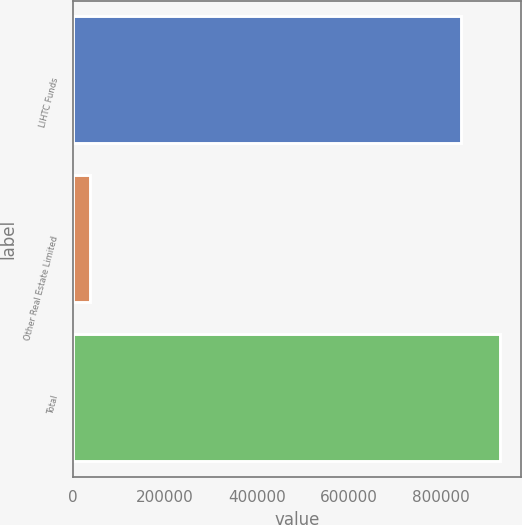Convert chart to OTSL. <chart><loc_0><loc_0><loc_500><loc_500><bar_chart><fcel>LIHTC Funds<fcel>Other Real Estate Limited<fcel>Total<nl><fcel>844597<fcel>35512<fcel>929078<nl></chart> 